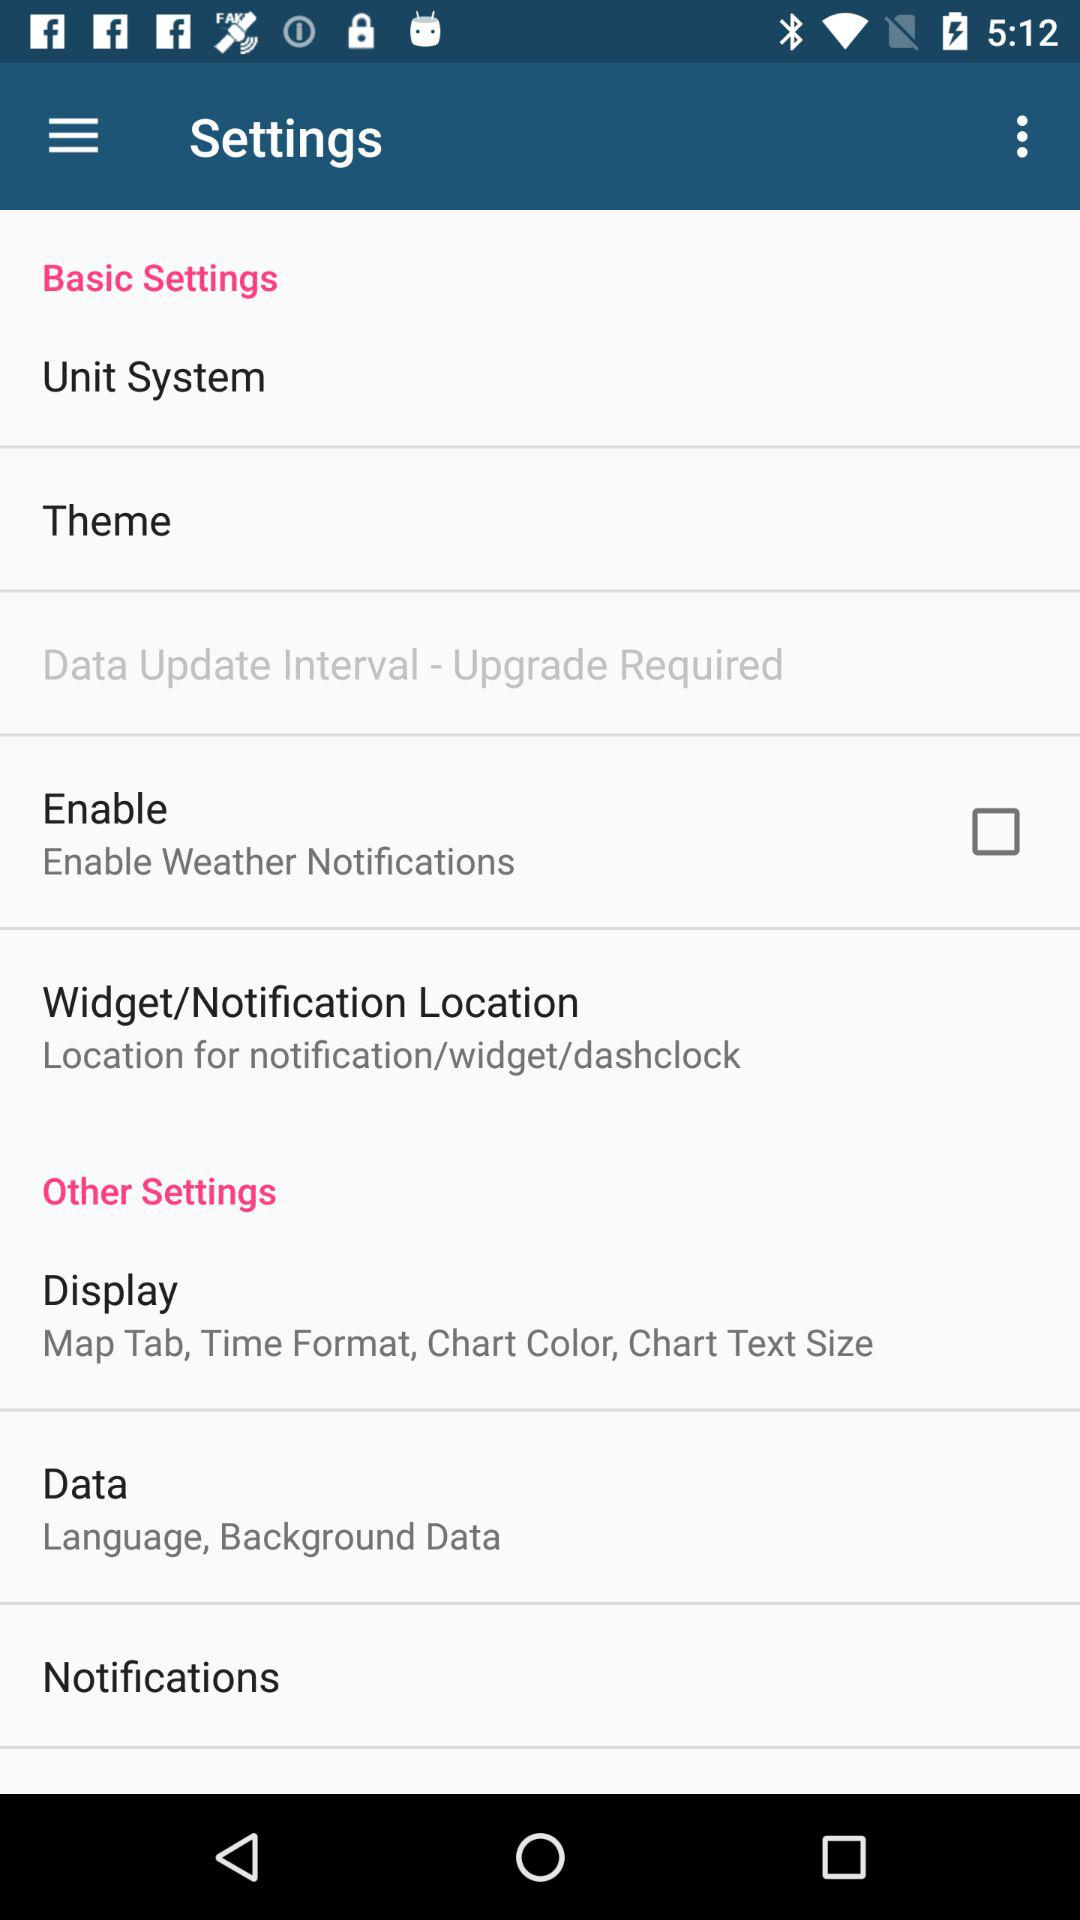What is the application name? The application name is "Settings". 